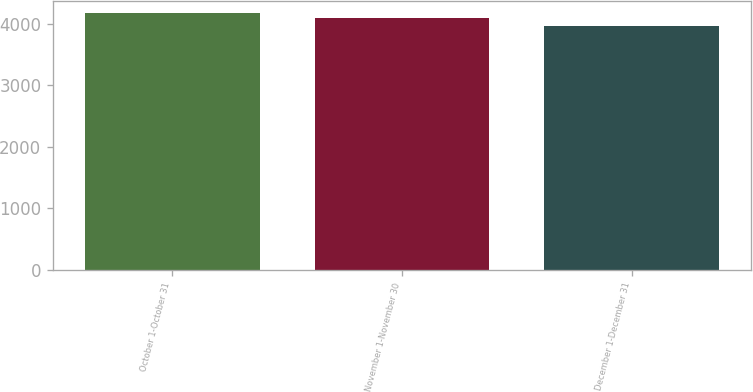Convert chart. <chart><loc_0><loc_0><loc_500><loc_500><bar_chart><fcel>October 1-October 31<fcel>November 1-November 30<fcel>December 1-December 31<nl><fcel>4169<fcel>4087<fcel>3970<nl></chart> 